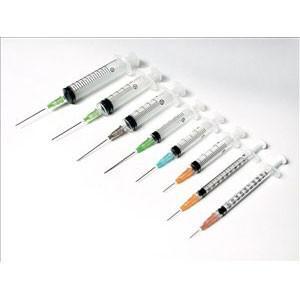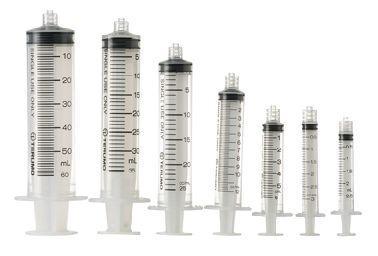The first image is the image on the left, the second image is the image on the right. For the images shown, is this caption "The left image has at least one syringe laying down in front of a box." true? Answer yes or no. No. The first image is the image on the left, the second image is the image on the right. For the images displayed, is the sentence "At least one packaged syringe is in front of a box, in one image." factually correct? Answer yes or no. No. 